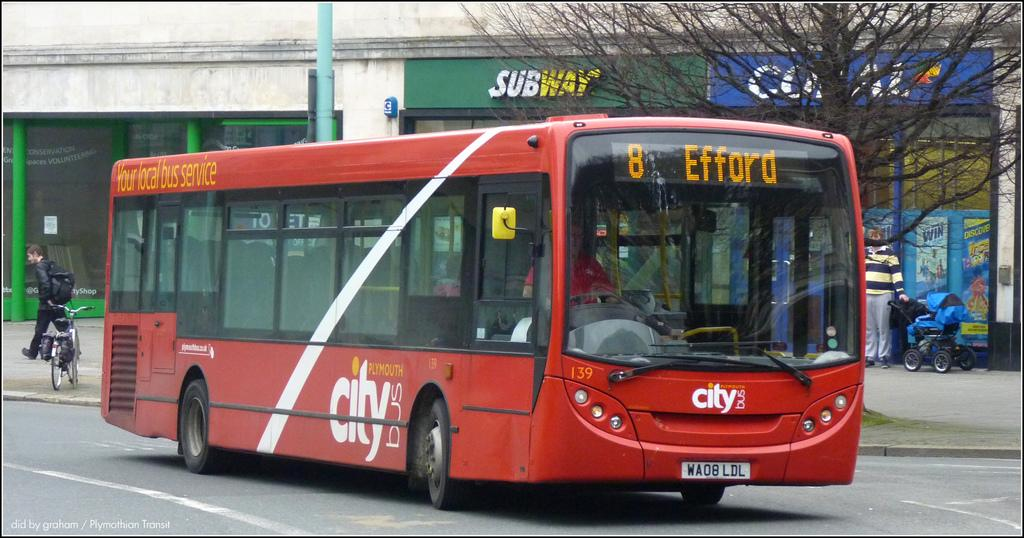<image>
Create a compact narrative representing the image presented. Red bus going to Efford in front of a Subway building. 